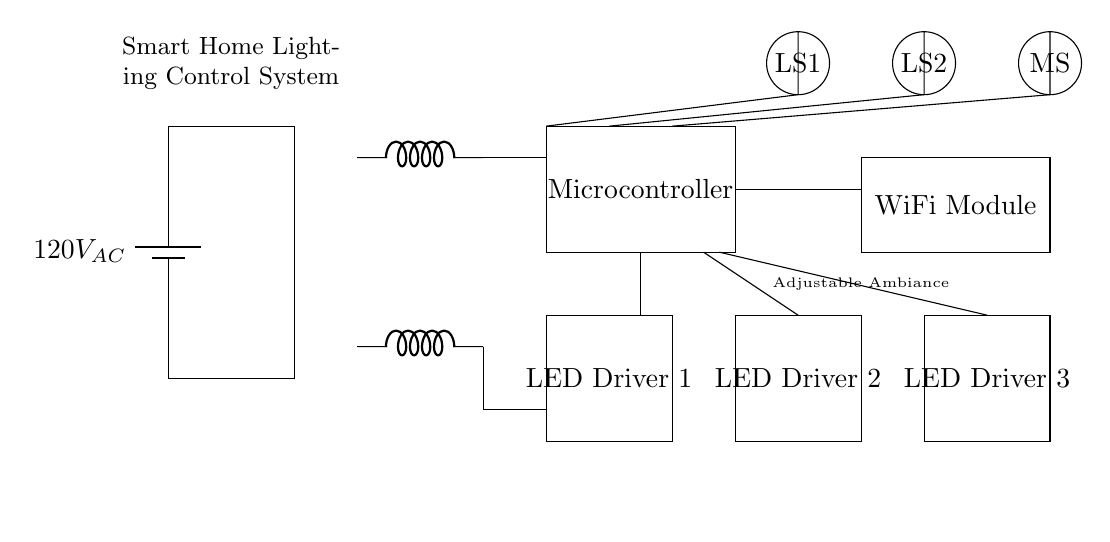What is the primary power source for this circuit? The primary power source is represented at the top of the circuit as a battery providing 120 volts alternating current.
Answer: 120 volts AC What component is responsible for controlling the lighting? The microcontroller located in the rectangular box is responsible for controlling the lighting features of the system.
Answer: Microcontroller How many LED drivers are present in this circuit? The circuit diagram indicates there are three LED drivers, each represented by a rectangle labeled sequentially.
Answer: Three What type of sensor is indicated for detecting movement? The movement detection is handled by a motion sensor depicted as a circle labeled MS in the circuit.
Answer: Motion sensor What system connectivity module is used for this device? The WiFi module is a rectangle located in the circuit, highlighting its role in system connectivity.
Answer: WiFi module How is the light intensity calculated in this circuit? The light intensity is inferred from the inputs received from the light sensors, which interact with the microcontroller to adjust the LEDs accordingly.
Answer: By light sensors What additional feature is indicated below the circuit? The label "Adjustable Ambiance" is provided under the circuit, suggesting that the primary feature of this smart lighting system is its capability to adjust ambiance levels.
Answer: Adjustable Ambiance 